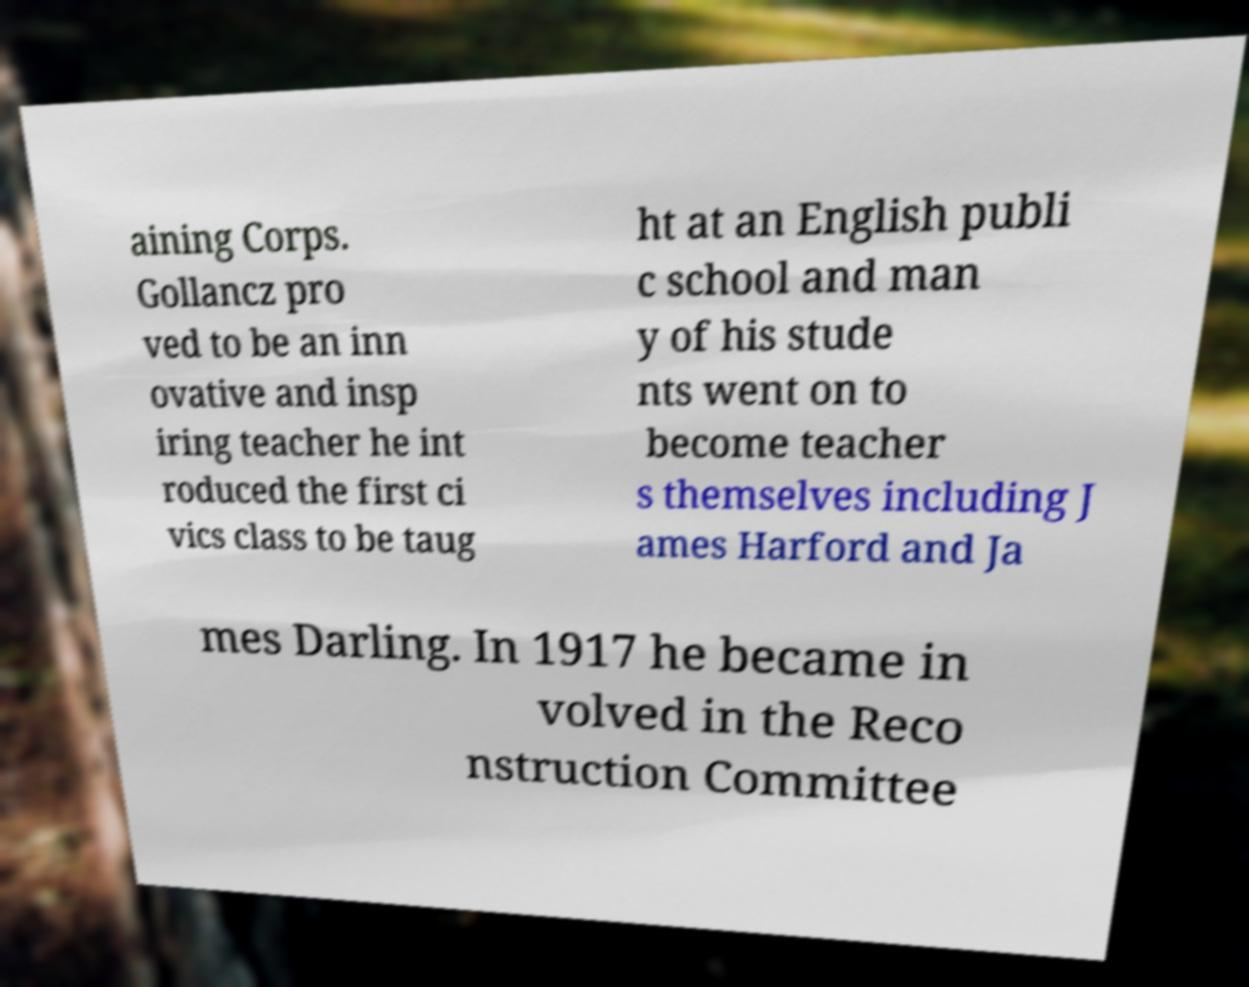For documentation purposes, I need the text within this image transcribed. Could you provide that? aining Corps. Gollancz pro ved to be an inn ovative and insp iring teacher he int roduced the first ci vics class to be taug ht at an English publi c school and man y of his stude nts went on to become teacher s themselves including J ames Harford and Ja mes Darling. In 1917 he became in volved in the Reco nstruction Committee 